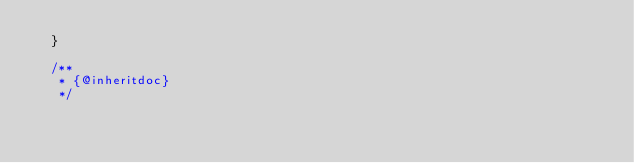<code> <loc_0><loc_0><loc_500><loc_500><_PHP_>  }

  /**
   * {@inheritdoc}
   */</code> 